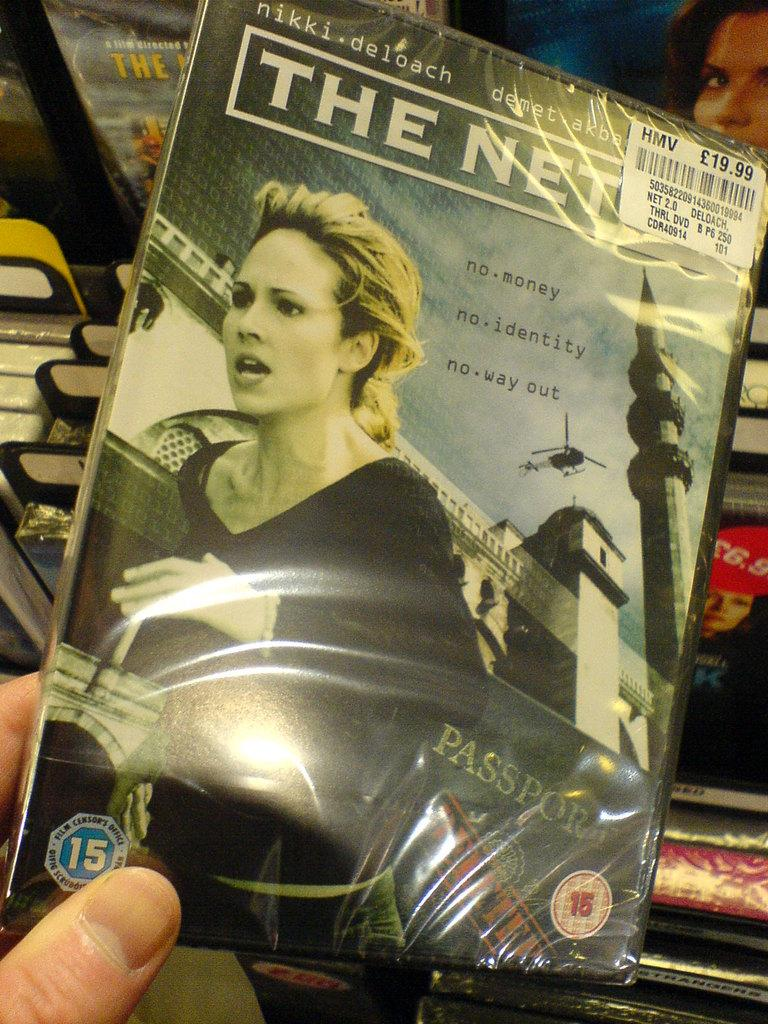<image>
Create a compact narrative representing the image presented. A movie has a price tag of 19.99 and a woman running on the cover. 